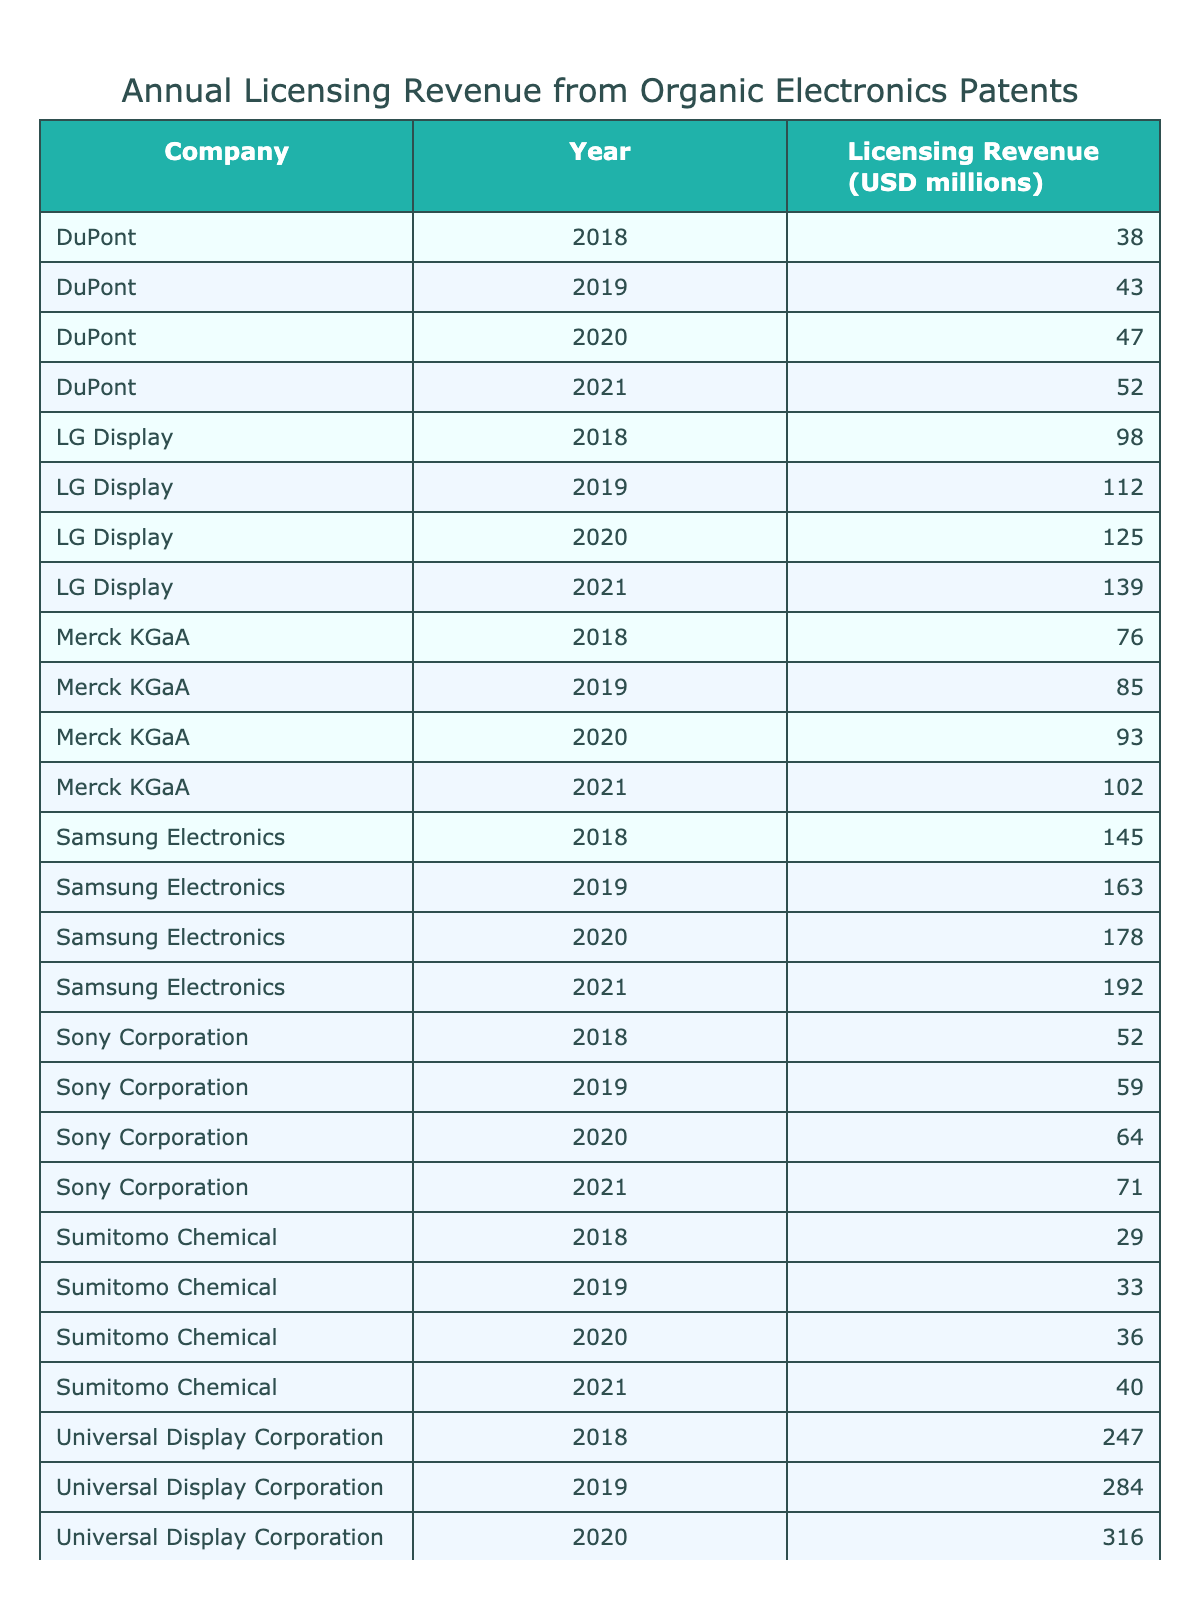What was the licensing revenue for Universal Display Corporation in 2021? The table shows the licensing revenue for each company in 2021, where Universal Display Corporation's revenue is listed as 353 million USD.
Answer: 353 million USD Which company had the highest total licensing revenue from 2018 to 2021? To find the company with the highest total revenue, we sum the revenues for each company: Universal Display Corporation (247 + 284 + 316 + 353 = 1200 million), Samsung Electronics (145 + 163 + 178 + 192 = 678 million), LG Display (98 + 112 + 125 + 139 = 474 million), Merck KGaA (76 + 85 + 93 + 102 = 356 million), Sony Corporation (52 + 59 + 64 + 71 = 246 million), DuPont (38 + 43 + 47 + 52 = 180 million), and Sumitomo Chemical (29 + 33 + 36 + 40 = 138 million). The highest is Universal Display Corporation with 1200 million USD.
Answer: Universal Display Corporation What was the average licensing revenue for LG Display from 2018 to 2021? The total revenue for LG Display is 98 + 112 + 125 + 139 = 474 million. Dividing by the number of years (4), we get 474/4 = 118.5 million.
Answer: 118.5 million USD Did Merck KGaA's licensing revenue increase every year from 2018 to 2021? By examining the table, the revenues for Merck KGaA are 76, 85, 93, and 102 million for the respective years, which shows a consistent increase each year.
Answer: Yes What was the difference in licensing revenues between Samsung Electronics and Sony Corporation in 2020? In 2020, Samsung Electronics had a revenue of 178 million and Sony Corporation had 64 million. The difference is 178 - 64 = 114 million.
Answer: 114 million USD Which company had the lowest licensing revenue in 2019? Looking at the 2019 row for each company, we identify the revenues: Samsung Electronics (163), LG Display (112), Universal Display Corporation (284), Merck KGaA (85), Sony Corporation (59), DuPont (43), and Sumitomo Chemical (33). The lowest is Sumitomo Chemical with 33 million USD.
Answer: Sumitomo Chemical What is the total licensing revenue from all companies in 2020? Adding the revenues for 2020 from all companies: Samsung Electronics (178) + LG Display (125) + Universal Display Corporation (316) + Merck KGaA (93) + Sony Corporation (64) + DuPont (47) + Sumitomo Chemical (36) = 819 million USD.
Answer: 819 million USD Which company had the greatest percentage increase in revenue from 2018 to 2021? To find the percentage increase for each, we calculate: Samsung Electronics: (192 - 145)/145 * 100 = 32.41%, LG Display: (139 - 98)/98 * 100 = 41.84%, Universal Display Corporation: (353 - 247)/247 * 100 = 42.83%, Merck KGaA: (102 - 76)/76 * 100 = 34.21%, Sony Corporation: (71 - 52)/52 * 100 = 36.54%, DuPont: (52 - 38)/38 * 100 = 36.84%, Sumitomo Chemical: (40 - 29)/29 * 100 = 37.93%. LG Display has the highest percentage increase.
Answer: LG Display What was the total licensing revenue for DuPont over the four years? Summing DuPont's revenues: 38 + 43 + 47 + 52 = 180 million translates to the total over the years.
Answer: 180 million USD 